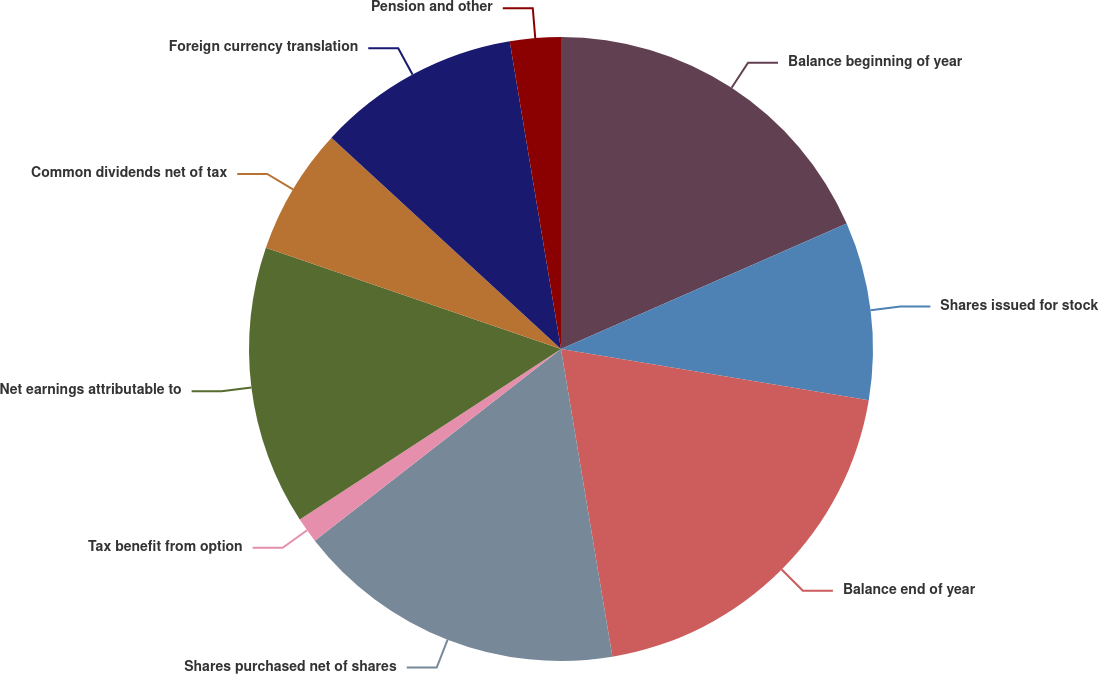Convert chart. <chart><loc_0><loc_0><loc_500><loc_500><pie_chart><fcel>Balance beginning of year<fcel>Shares issued for stock<fcel>Balance end of year<fcel>Shares purchased net of shares<fcel>Tax benefit from option<fcel>Net earnings attributable to<fcel>Common dividends net of tax<fcel>Foreign currency translation<fcel>Pension and other<nl><fcel>18.42%<fcel>9.21%<fcel>19.74%<fcel>17.11%<fcel>1.32%<fcel>14.47%<fcel>6.58%<fcel>10.53%<fcel>2.63%<nl></chart> 